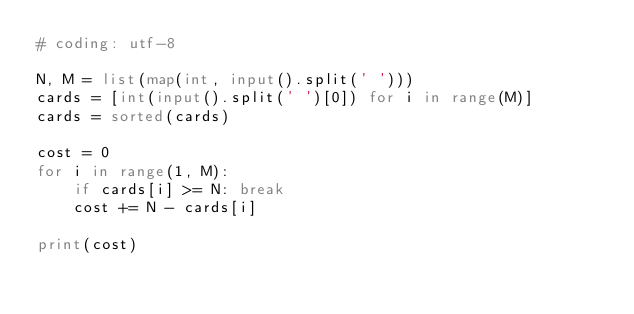<code> <loc_0><loc_0><loc_500><loc_500><_Python_># coding: utf-8

N, M = list(map(int, input().split(' ')))
cards = [int(input().split(' ')[0]) for i in range(M)]
cards = sorted(cards)

cost = 0
for i in range(1, M):
    if cards[i] >= N: break
    cost += N - cards[i]

print(cost)

</code> 